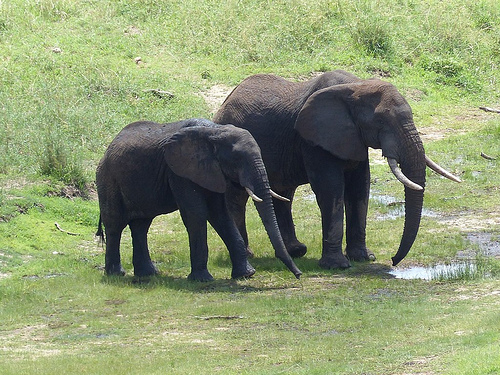Does the large elephant appear to be walking? Yes, the large elephant appears to be walking in this picture. 